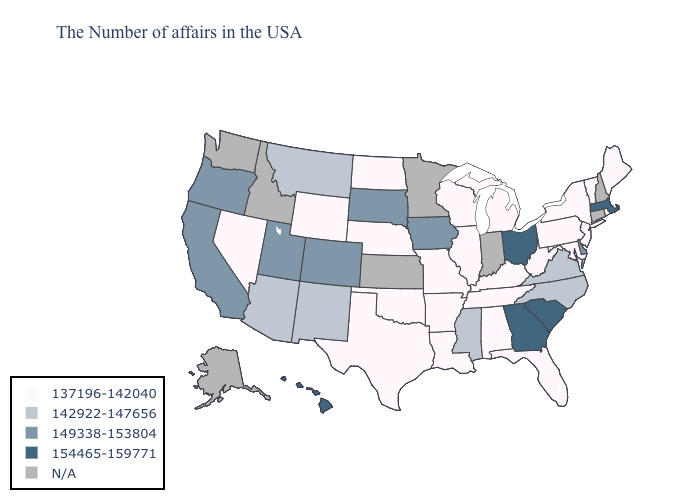Name the states that have a value in the range 149338-153804?
Be succinct. Delaware, Iowa, South Dakota, Colorado, Utah, California, Oregon. Among the states that border Oregon , which have the highest value?
Be succinct. California. Does the first symbol in the legend represent the smallest category?
Answer briefly. Yes. What is the value of Kentucky?
Quick response, please. 137196-142040. Which states have the lowest value in the Northeast?
Keep it brief. Maine, Rhode Island, Vermont, New York, New Jersey, Pennsylvania. How many symbols are there in the legend?
Keep it brief. 5. What is the value of West Virginia?
Concise answer only. 137196-142040. What is the value of Texas?
Quick response, please. 137196-142040. Does the first symbol in the legend represent the smallest category?
Answer briefly. Yes. What is the value of Oregon?
Be succinct. 149338-153804. Does Tennessee have the lowest value in the USA?
Short answer required. Yes. What is the value of Indiana?
Write a very short answer. N/A. Does the first symbol in the legend represent the smallest category?
Write a very short answer. Yes. Does the map have missing data?
Quick response, please. Yes. Name the states that have a value in the range 154465-159771?
Short answer required. Massachusetts, South Carolina, Ohio, Georgia, Hawaii. 